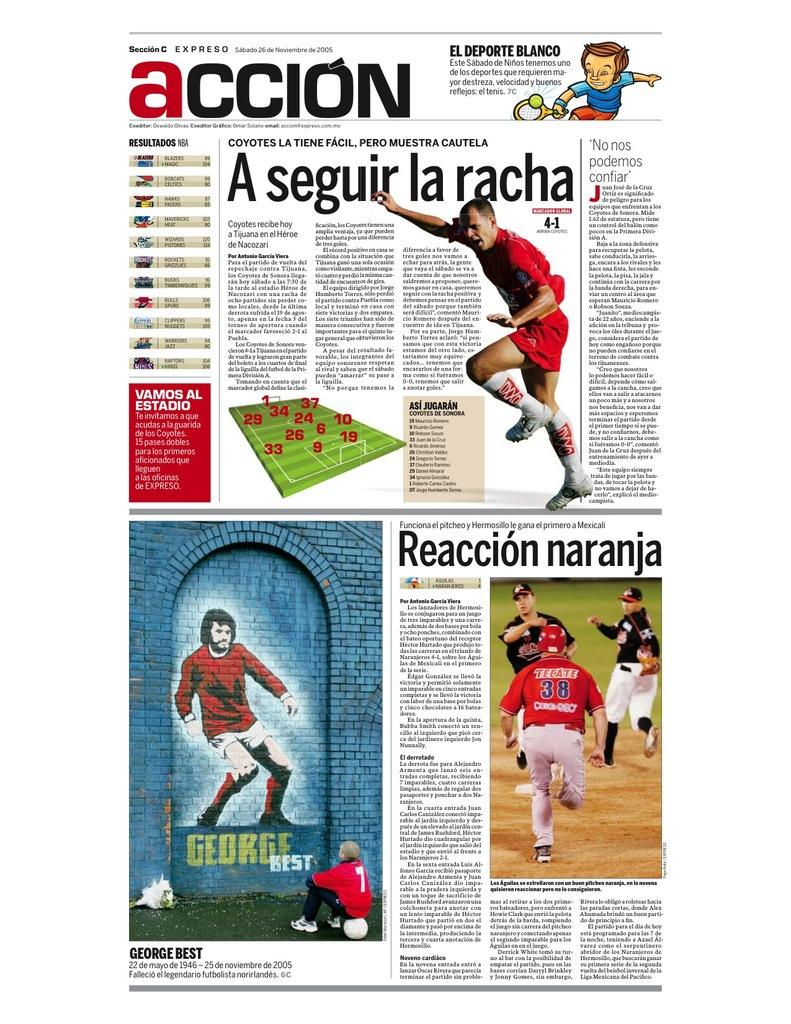<image>
Share a concise interpretation of the image provided. A foreign magazine features pictures of an unknown footballer, a baseball player and George Best 